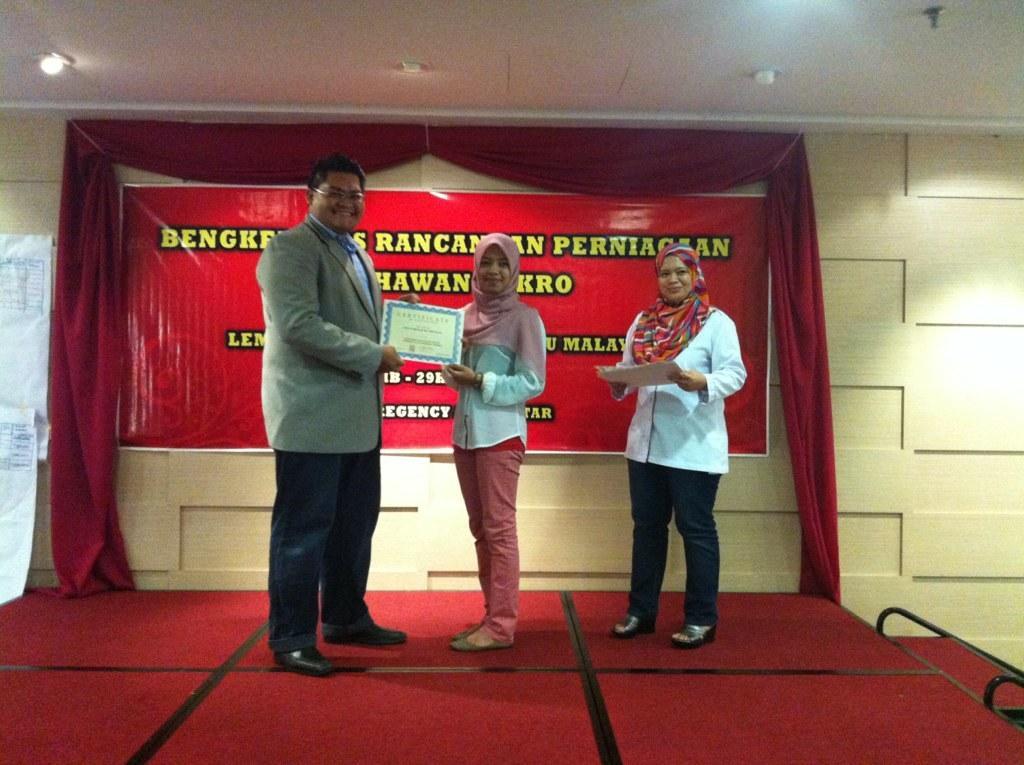How would you summarize this image in a sentence or two? In this picture we can see one person is giving certificates to another person, beside one woman is standing and holding some certifications. Back side, we can see one banner to the wall. 